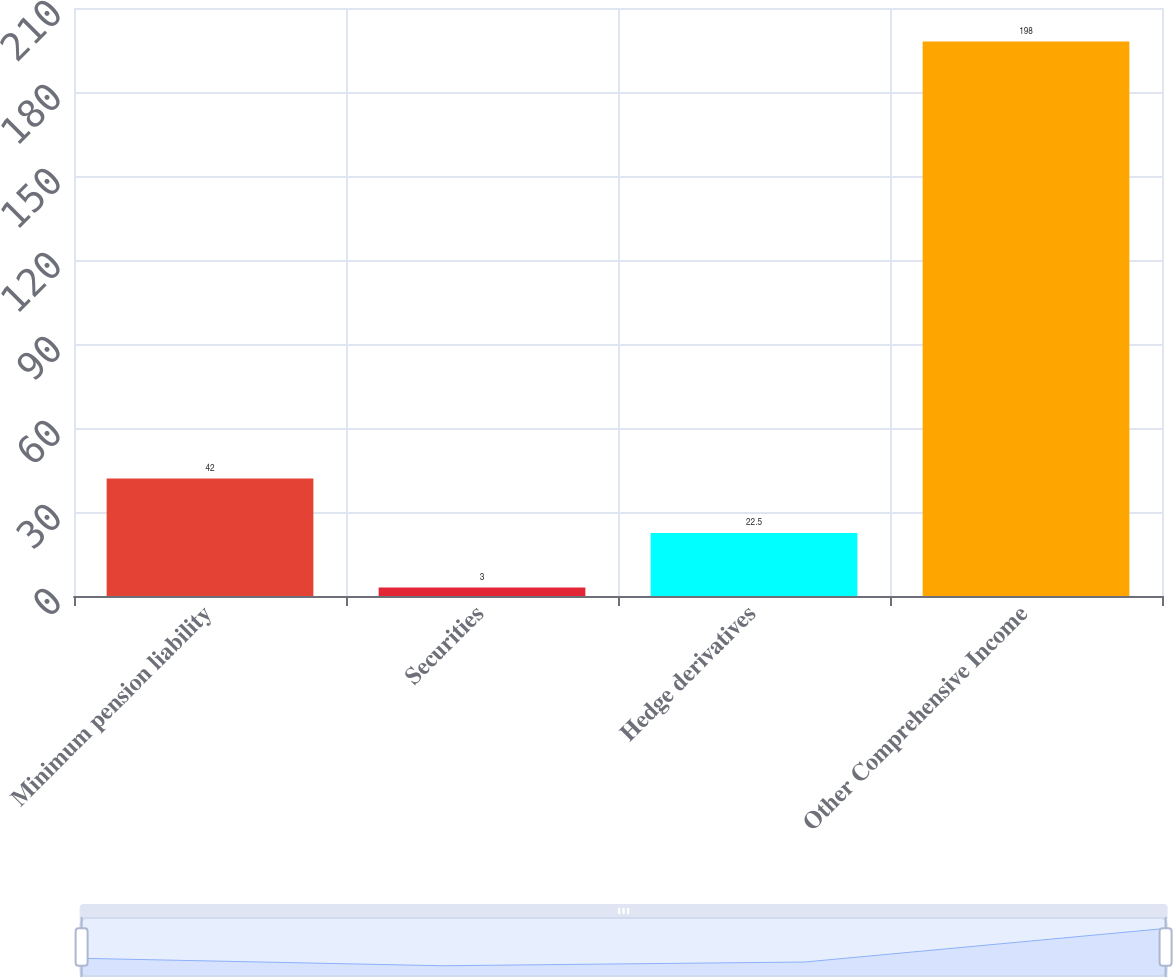Convert chart to OTSL. <chart><loc_0><loc_0><loc_500><loc_500><bar_chart><fcel>Minimum pension liability<fcel>Securities<fcel>Hedge derivatives<fcel>Other Comprehensive Income<nl><fcel>42<fcel>3<fcel>22.5<fcel>198<nl></chart> 